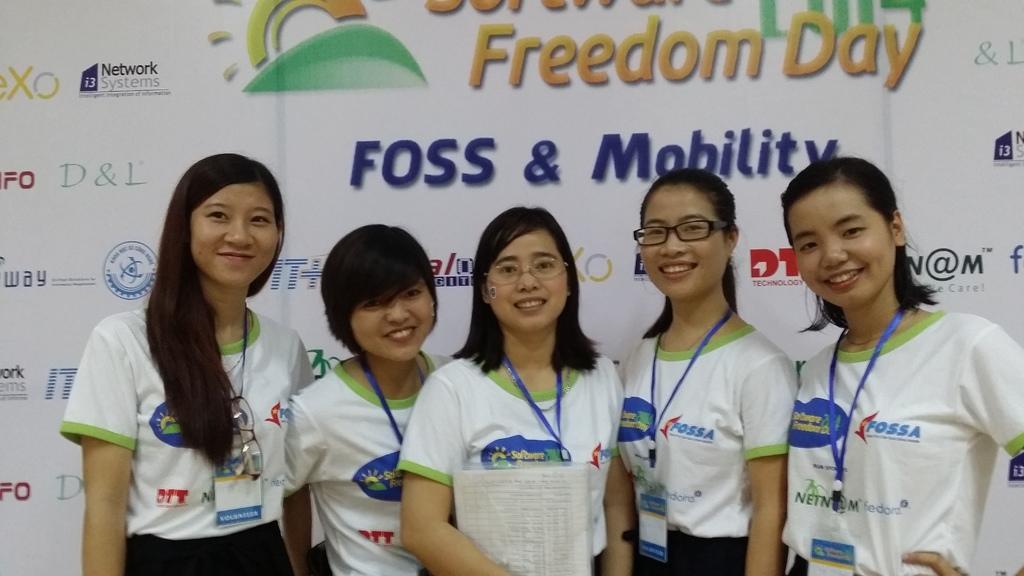How would you summarize this image in a sentence or two? At the bottom of this image, there are women, wearing badges, smiling and standing. One of them is holding a document. In the background, there is a banner. 